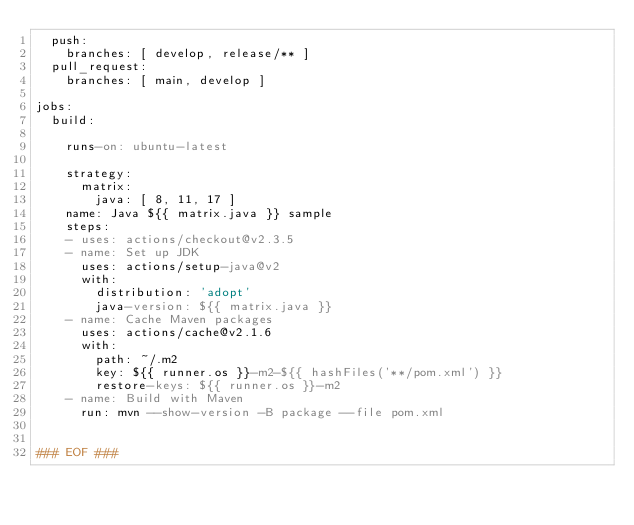<code> <loc_0><loc_0><loc_500><loc_500><_YAML_>  push:
    branches: [ develop, release/** ]
  pull_request:
    branches: [ main, develop ]

jobs:
  build:

    runs-on: ubuntu-latest

    strategy:
      matrix:
        java: [ 8, 11, 17 ]
    name: Java ${{ matrix.java }} sample
    steps:
    - uses: actions/checkout@v2.3.5
    - name: Set up JDK
      uses: actions/setup-java@v2
      with:
        distribution: 'adopt'
        java-version: ${{ matrix.java }}
    - name: Cache Maven packages
      uses: actions/cache@v2.1.6
      with:
        path: ~/.m2
        key: ${{ runner.os }}-m2-${{ hashFiles('**/pom.xml') }}
        restore-keys: ${{ runner.os }}-m2
    - name: Build with Maven
      run: mvn --show-version -B package --file pom.xml


### EOF ###
</code> 